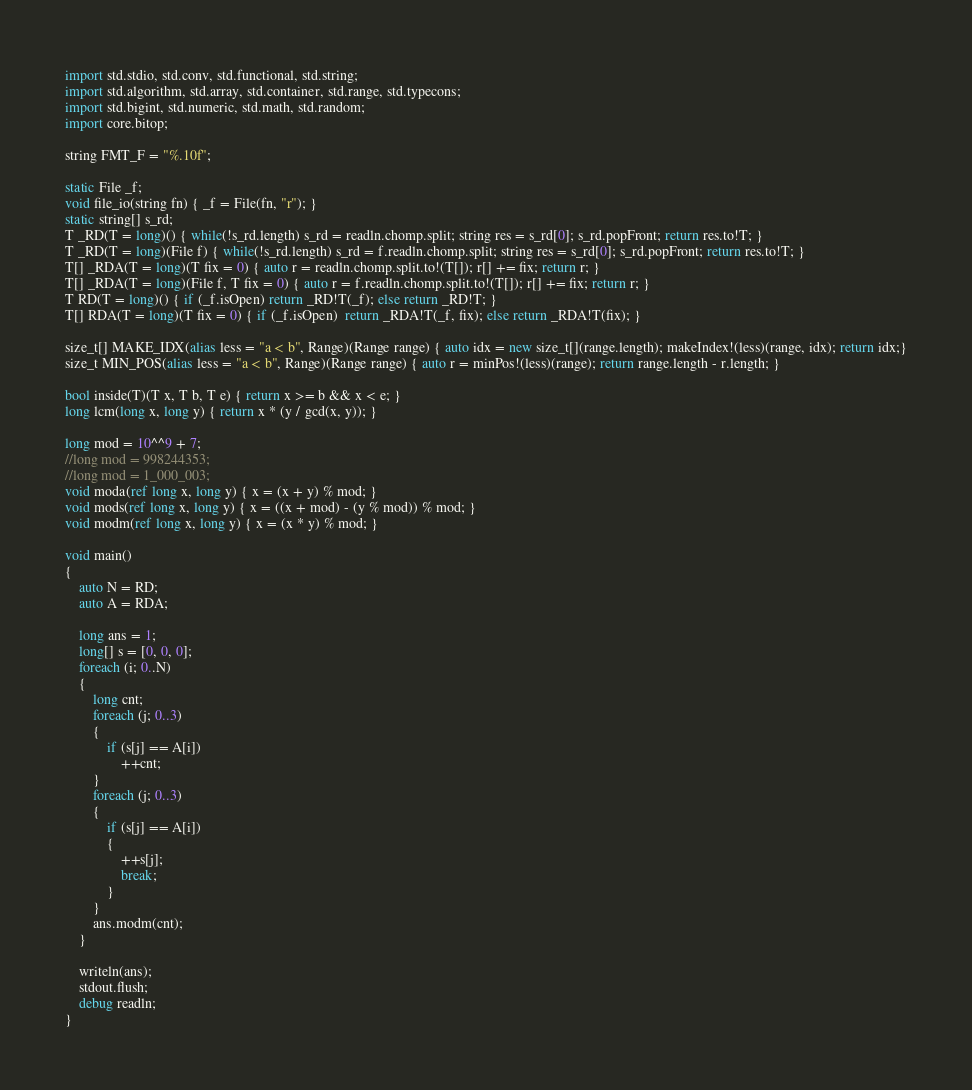<code> <loc_0><loc_0><loc_500><loc_500><_D_>import std.stdio, std.conv, std.functional, std.string;
import std.algorithm, std.array, std.container, std.range, std.typecons;
import std.bigint, std.numeric, std.math, std.random;
import core.bitop;

string FMT_F = "%.10f";

static File _f;
void file_io(string fn) { _f = File(fn, "r"); }
static string[] s_rd;
T _RD(T = long)() { while(!s_rd.length) s_rd = readln.chomp.split; string res = s_rd[0]; s_rd.popFront; return res.to!T; }
T _RD(T = long)(File f) { while(!s_rd.length) s_rd = f.readln.chomp.split; string res = s_rd[0]; s_rd.popFront; return res.to!T; }
T[] _RDA(T = long)(T fix = 0) { auto r = readln.chomp.split.to!(T[]); r[] += fix; return r; }
T[] _RDA(T = long)(File f, T fix = 0) { auto r = f.readln.chomp.split.to!(T[]); r[] += fix; return r; }
T RD(T = long)() { if (_f.isOpen) return _RD!T(_f); else return _RD!T; }
T[] RDA(T = long)(T fix = 0) { if (_f.isOpen)  return _RDA!T(_f, fix); else return _RDA!T(fix); }

size_t[] MAKE_IDX(alias less = "a < b", Range)(Range range) { auto idx = new size_t[](range.length); makeIndex!(less)(range, idx); return idx;}
size_t MIN_POS(alias less = "a < b", Range)(Range range) { auto r = minPos!(less)(range); return range.length - r.length; }

bool inside(T)(T x, T b, T e) { return x >= b && x < e; }
long lcm(long x, long y) { return x * (y / gcd(x, y)); }

long mod = 10^^9 + 7;
//long mod = 998244353;
//long mod = 1_000_003;
void moda(ref long x, long y) { x = (x + y) % mod; }
void mods(ref long x, long y) { x = ((x + mod) - (y % mod)) % mod; }
void modm(ref long x, long y) { x = (x * y) % mod; }

void main()
{
	auto N = RD;
	auto A = RDA;

	long ans = 1;
	long[] s = [0, 0, 0];
	foreach (i; 0..N)
	{
		long cnt;
		foreach (j; 0..3)
		{
			if (s[j] == A[i]) 
				++cnt;
		}
		foreach (j; 0..3)
		{
			if (s[j] == A[i]) 
			{
				++s[j];
				break;
			}
		}
		ans.modm(cnt);
	}
	
	writeln(ans);
	stdout.flush;
	debug readln;
}</code> 